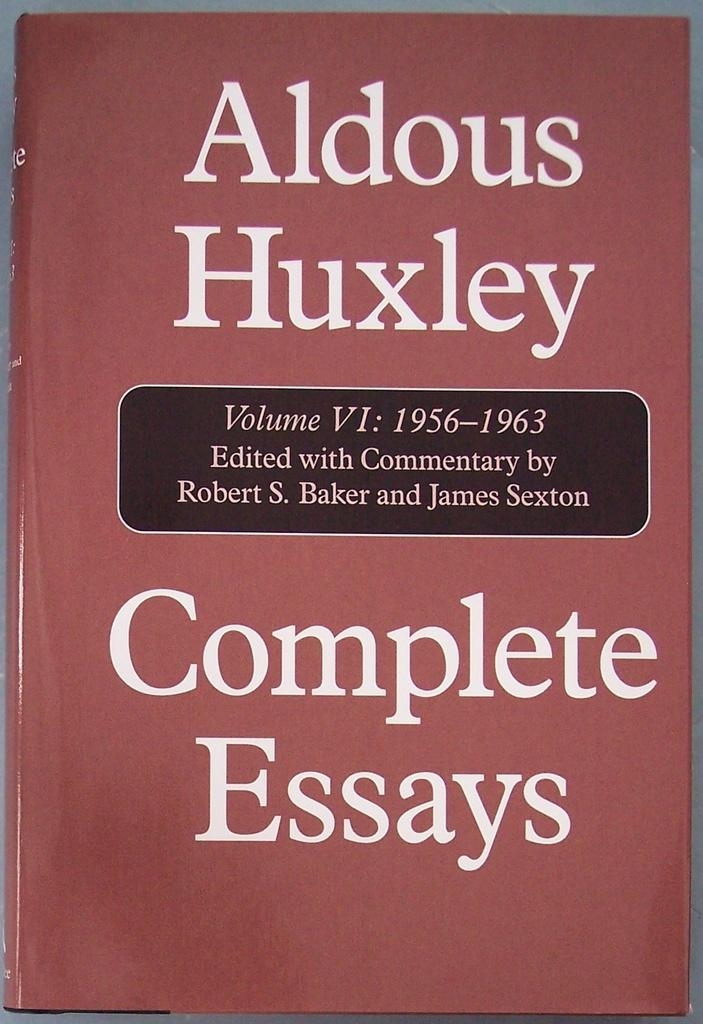<image>
Summarize the visual content of the image. The cover of the Complete Essays of Aldous Huxley Volume VI: 1956 - 1963 is shown. 